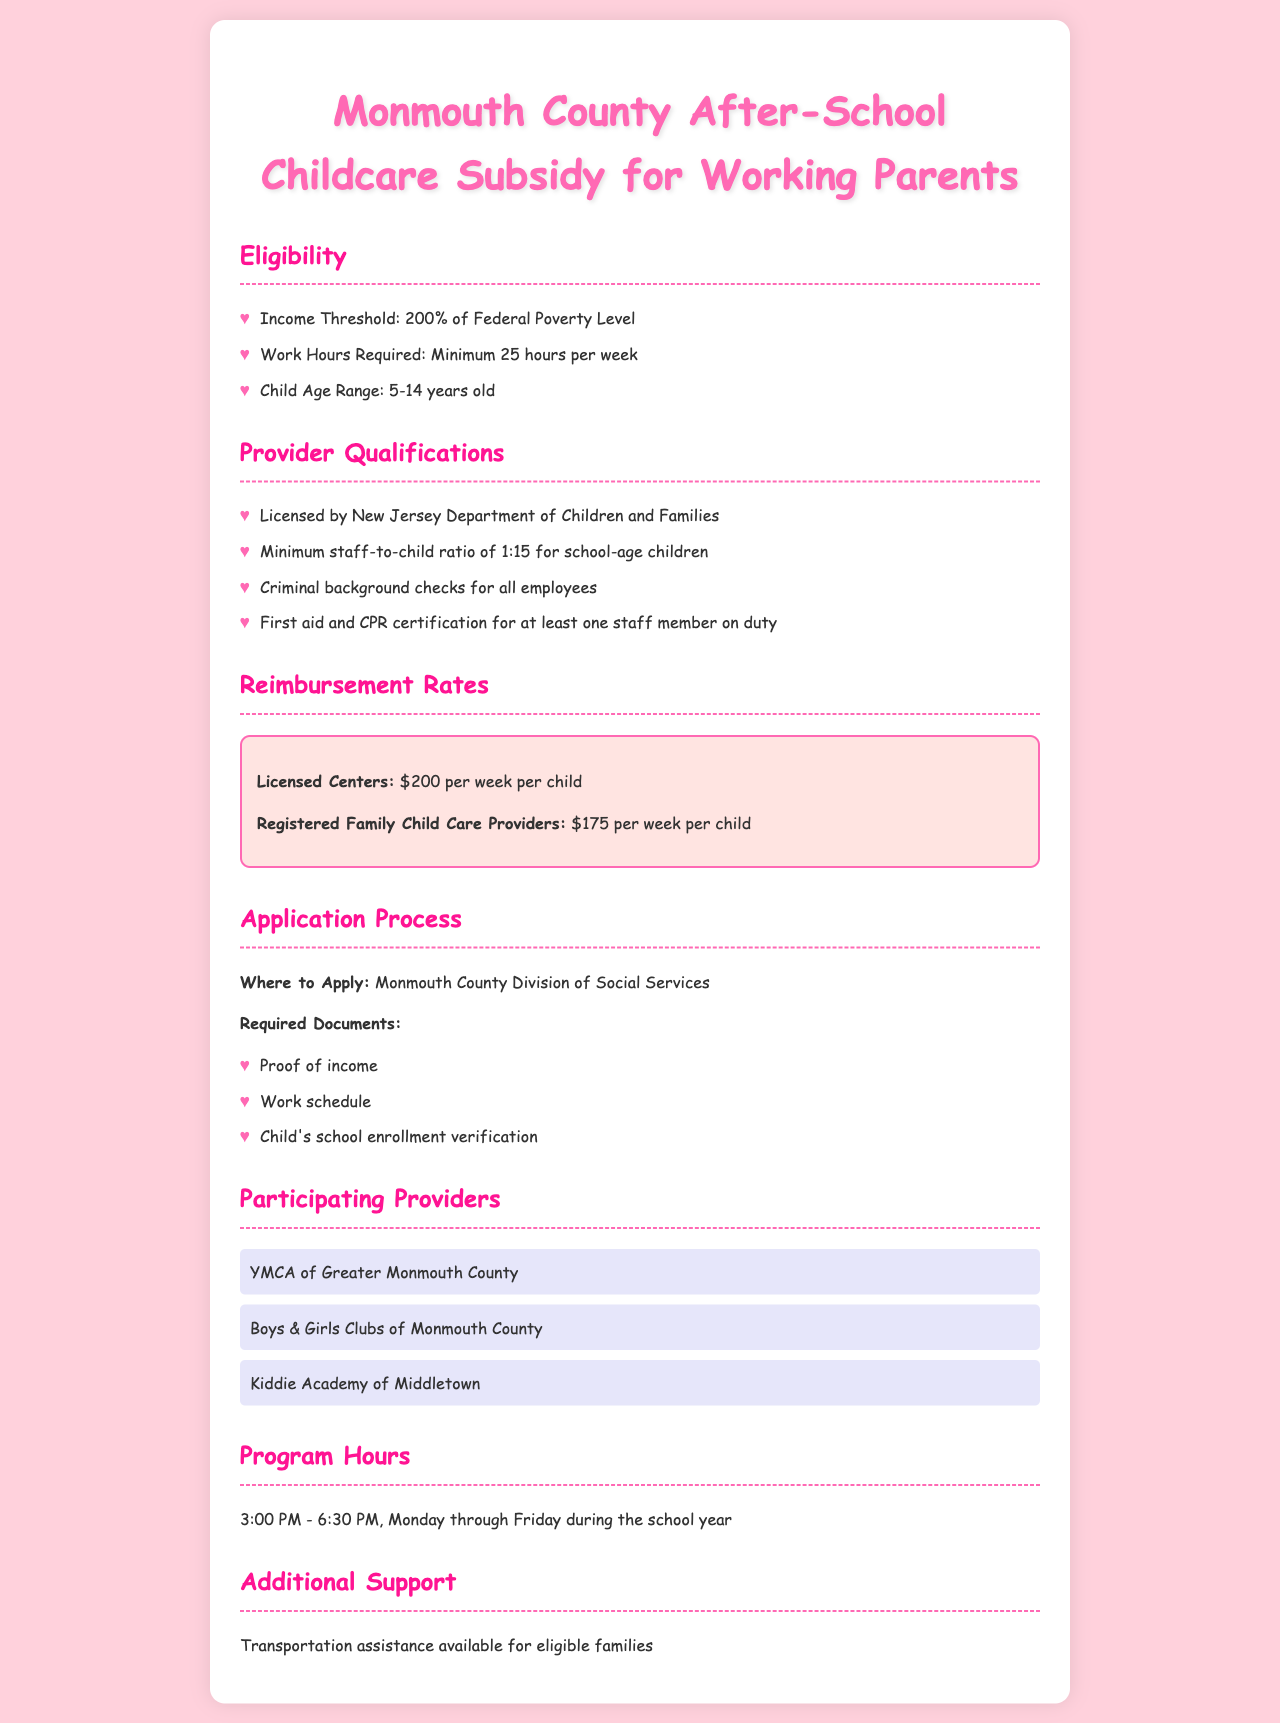what is the income threshold for eligibility? The income threshold for eligibility is defined in the document, stating it is 200% of Federal Poverty Level.
Answer: 200% of Federal Poverty Level how many hours per week do parents need to work to be eligible? The document mentions that parents must work a minimum of 25 hours per week to qualify for the subsidy.
Answer: Minimum 25 hours per week what is the staff-to-child ratio required for providers? The document specifies that there must be a minimum staff-to-child ratio of 1:15 for school-age children in licensed centers.
Answer: 1:15 how much is the reimbursement rate for licensed centers? The document clearly states that licensed centers receive $200 per week per child as reimbursement.
Answer: $200 per week per child where can parents apply for the childcare subsidy? According to the document, parents should apply at the Monmouth County Division of Social Services.
Answer: Monmouth County Division of Social Services what types of childcare providers are participating? The document lists several participating providers, including YMCA of Greater Monmouth County.
Answer: YMCA of Greater Monmouth County what certification must at least one staff member have? The document details that at least one staff member must have First aid and CPR certification.
Answer: First aid and CPR certification what are the program hours offered for after-school care? The document specifies that the program hours are from 3:00 PM to 6:30 PM during the school year.
Answer: 3:00 PM - 6:30 PM how old must the children be to qualify for after-school care? The document indicates that children must be in the age range of 5-14 years old to qualify.
Answer: 5-14 years old 